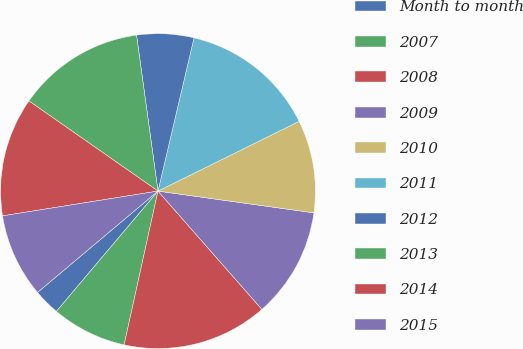Convert chart. <chart><loc_0><loc_0><loc_500><loc_500><pie_chart><fcel>Month to month<fcel>2007<fcel>2008<fcel>2009<fcel>2010<fcel>2011<fcel>2012<fcel>2013<fcel>2014<fcel>2015<nl><fcel>2.71%<fcel>7.71%<fcel>14.92%<fcel>11.32%<fcel>9.51%<fcel>14.02%<fcel>5.85%<fcel>13.12%<fcel>12.22%<fcel>8.61%<nl></chart> 